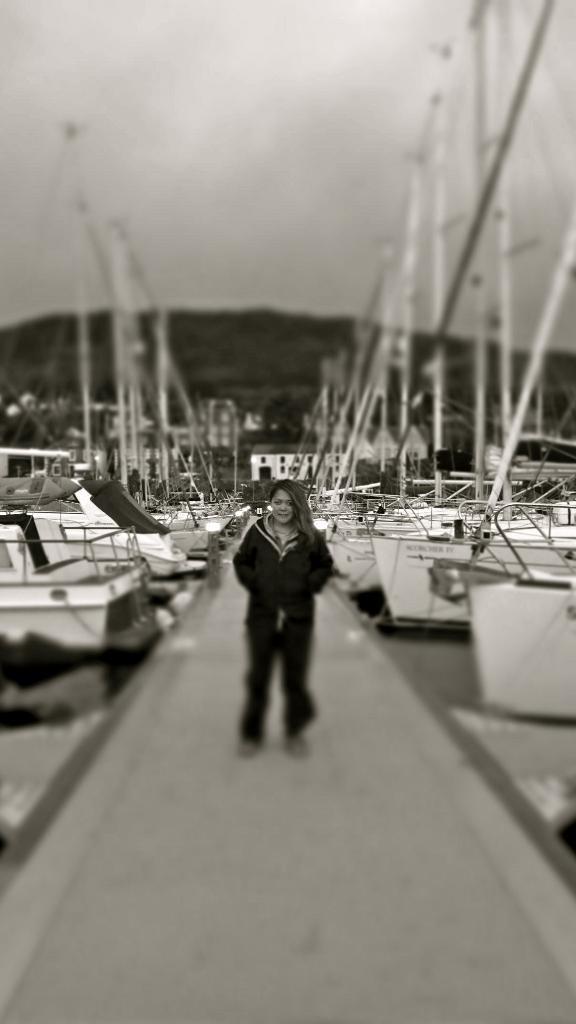What is the color scheme of the image? The image is black and white. What can be seen in the foreground of the image? There is a woman standing in the image. What is the woman doing in the image? The woman is giving a pose for the picture. What can be seen in the background of the image? There are many boats in the background of the image. What is visible at the top of the image? The sky is visible at the top of the image. What type of space suit is the woman wearing in the image? There is no space suit present in the image; it is a black and white picture of a woman giving a pose. Can you tell me how many sisters are standing next to the woman in the image? There is no mention of a sister or any other person in the image besides the woman. 